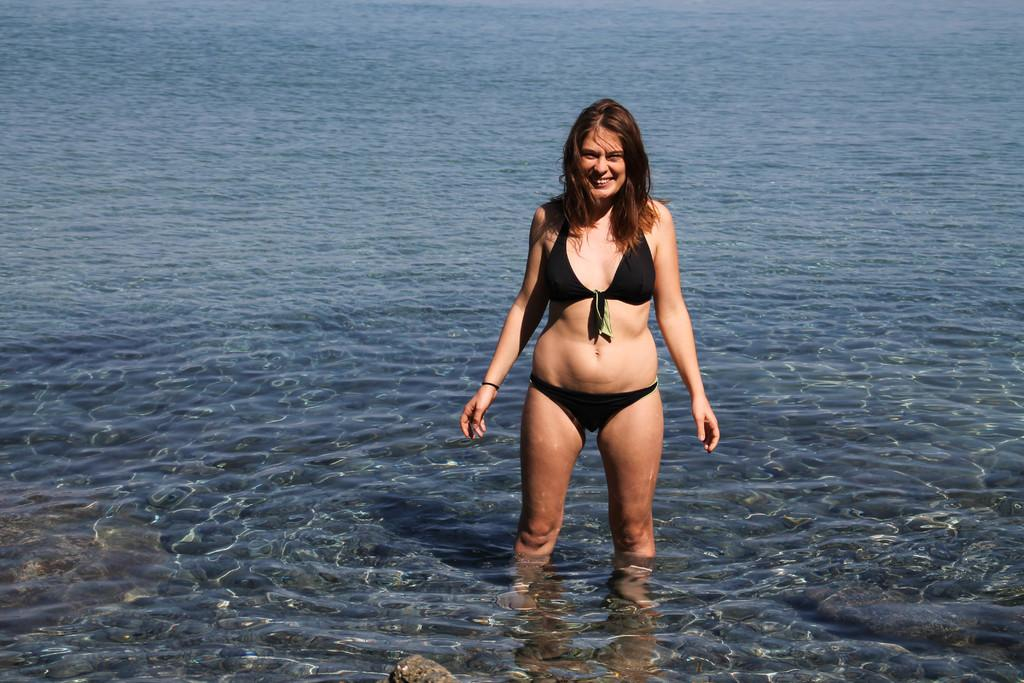What is the primary element present in the image? There is water in the image. What is the woman doing in the water? The woman is standing in the water. What is the woman's facial expression? The woman is smiling. What can be seen in the front of the image? There is a rock in the front of the image. Can you see the woman's knee in the image? The image does not show the woman's knee, as it only shows her from the waist up. 